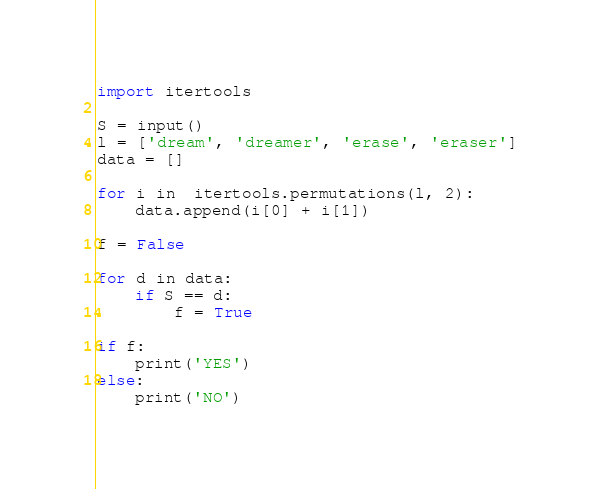<code> <loc_0><loc_0><loc_500><loc_500><_Python_>import itertools

S = input()
l = ['dream', 'dreamer', 'erase', 'eraser']
data = []

for i in  itertools.permutations(l, 2):
    data.append(i[0] + i[1])

f = False

for d in data:
    if S == d:
        f = True

if f:
    print('YES')
else:
    print('NO')
</code> 